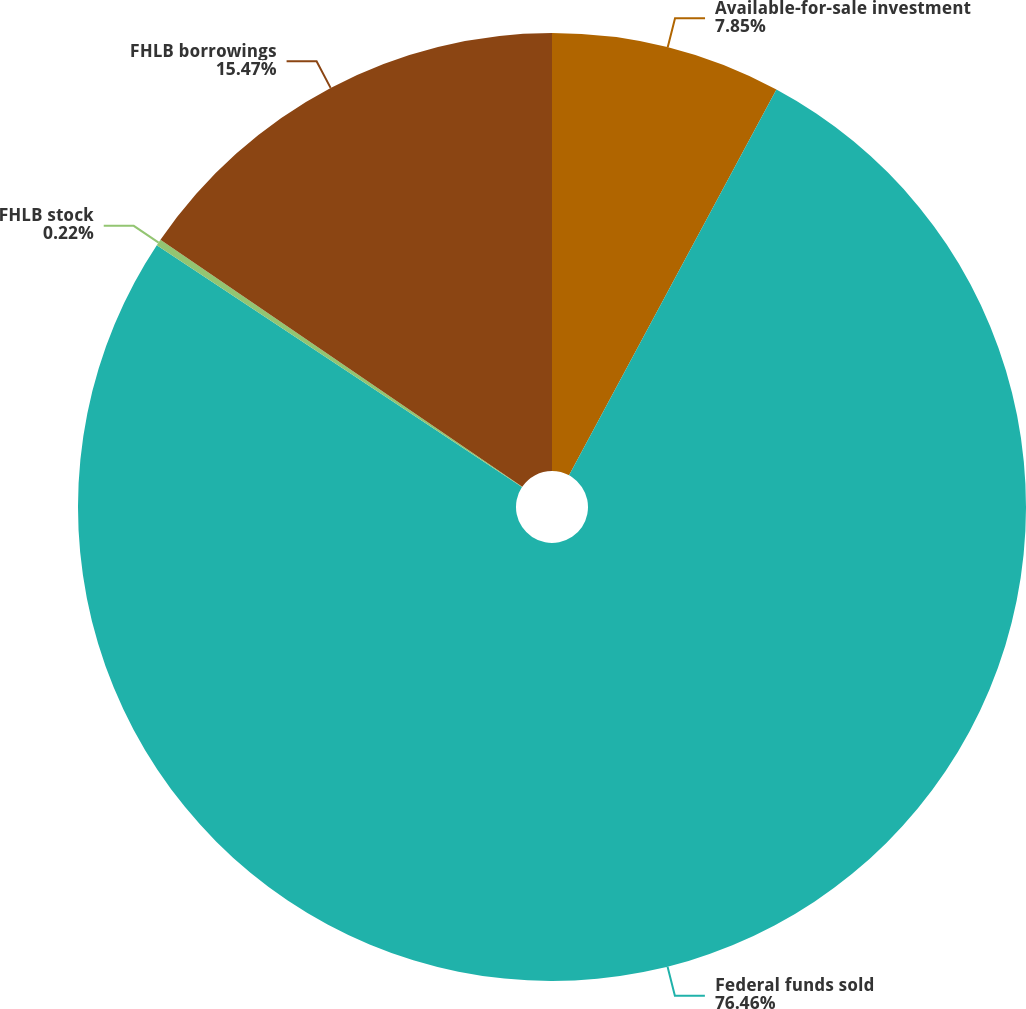Convert chart to OTSL. <chart><loc_0><loc_0><loc_500><loc_500><pie_chart><fcel>Available-for-sale investment<fcel>Federal funds sold<fcel>FHLB stock<fcel>FHLB borrowings<nl><fcel>7.85%<fcel>76.46%<fcel>0.22%<fcel>15.47%<nl></chart> 